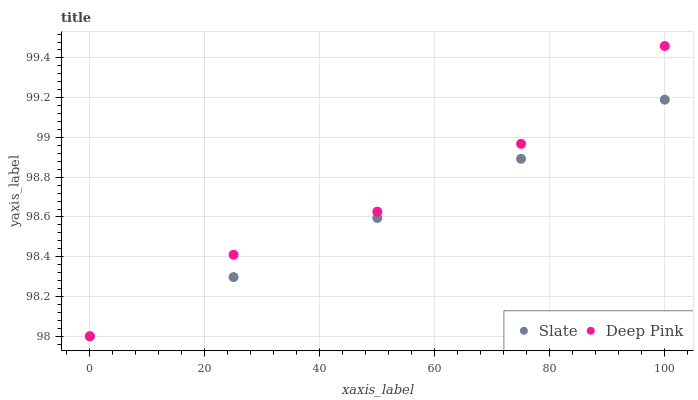Does Slate have the minimum area under the curve?
Answer yes or no. Yes. Does Deep Pink have the maximum area under the curve?
Answer yes or no. Yes. Does Deep Pink have the minimum area under the curve?
Answer yes or no. No. Is Slate the smoothest?
Answer yes or no. Yes. Is Deep Pink the roughest?
Answer yes or no. Yes. Is Deep Pink the smoothest?
Answer yes or no. No. Does Slate have the lowest value?
Answer yes or no. Yes. Does Deep Pink have the highest value?
Answer yes or no. Yes. Does Deep Pink intersect Slate?
Answer yes or no. Yes. Is Deep Pink less than Slate?
Answer yes or no. No. Is Deep Pink greater than Slate?
Answer yes or no. No. 